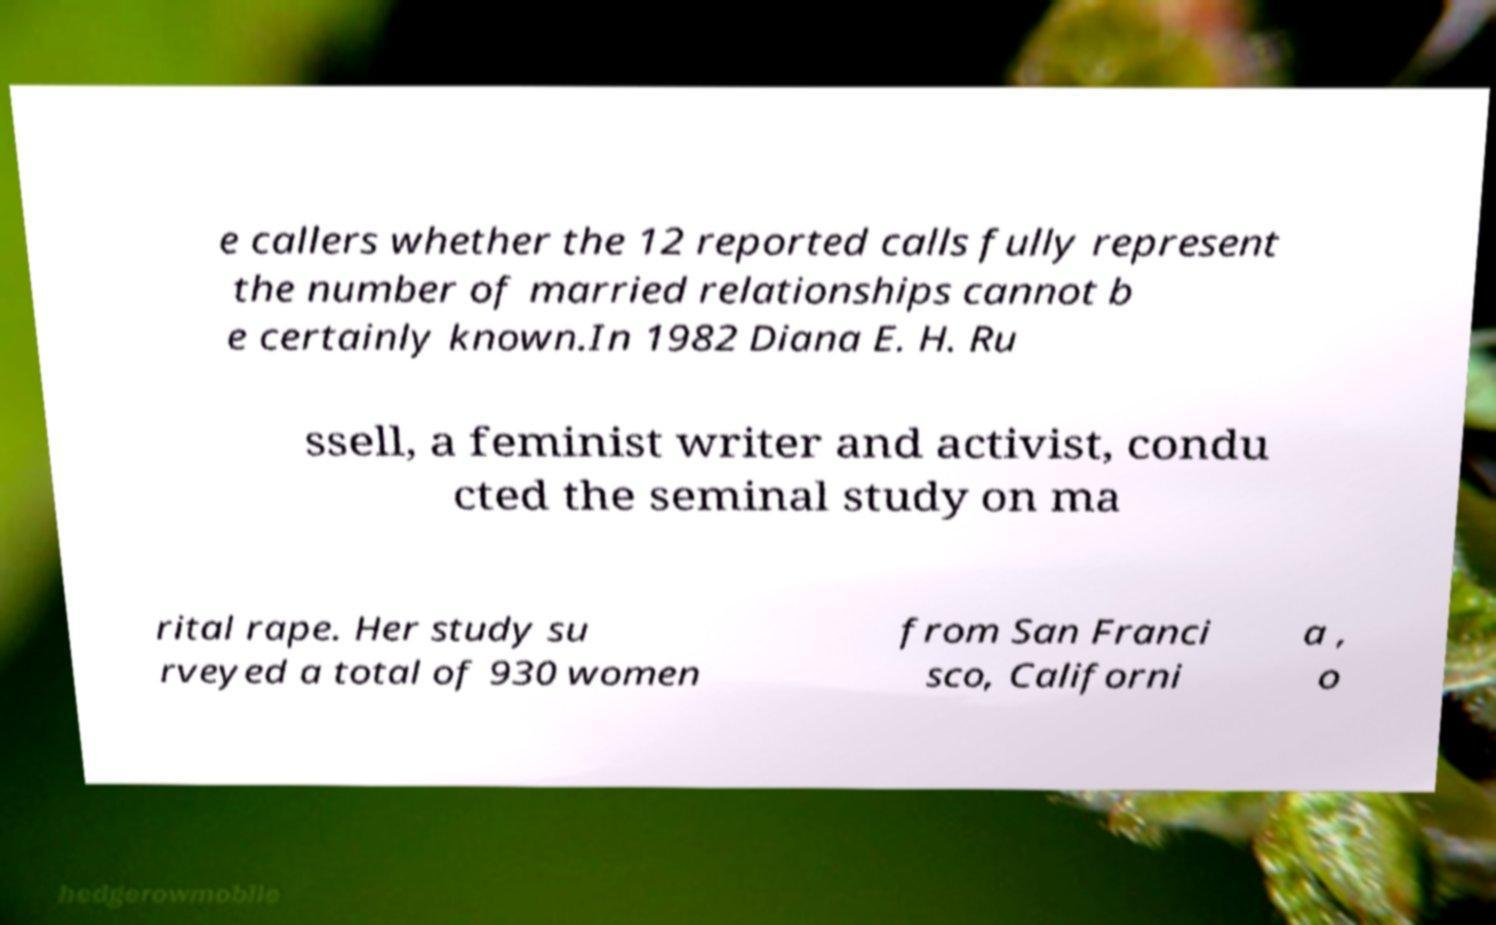Can you accurately transcribe the text from the provided image for me? e callers whether the 12 reported calls fully represent the number of married relationships cannot b e certainly known.In 1982 Diana E. H. Ru ssell, a feminist writer and activist, condu cted the seminal study on ma rital rape. Her study su rveyed a total of 930 women from San Franci sco, Californi a , o 